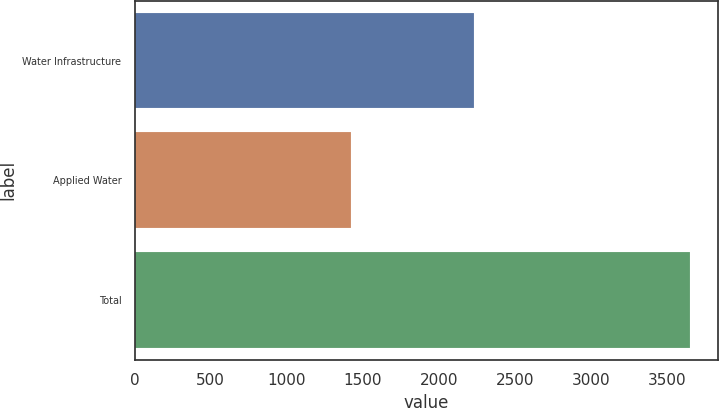Convert chart to OTSL. <chart><loc_0><loc_0><loc_500><loc_500><bar_chart><fcel>Water Infrastructure<fcel>Applied Water<fcel>Total<nl><fcel>2231<fcel>1422<fcel>3653<nl></chart> 